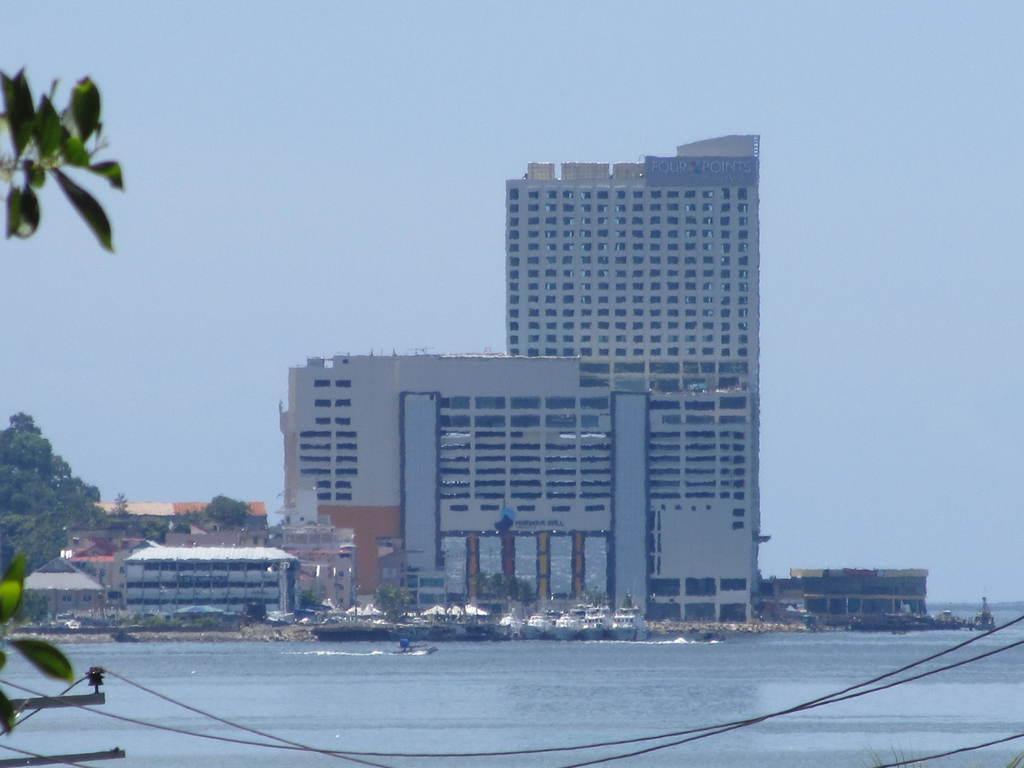Please provide a concise description of this image. In the image we can see there are buildings and these are the windows of the building. This is a water, tree and a sky, these are the electric wires and boat in the water. 